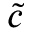Convert formula to latex. <formula><loc_0><loc_0><loc_500><loc_500>\tilde { c }</formula> 